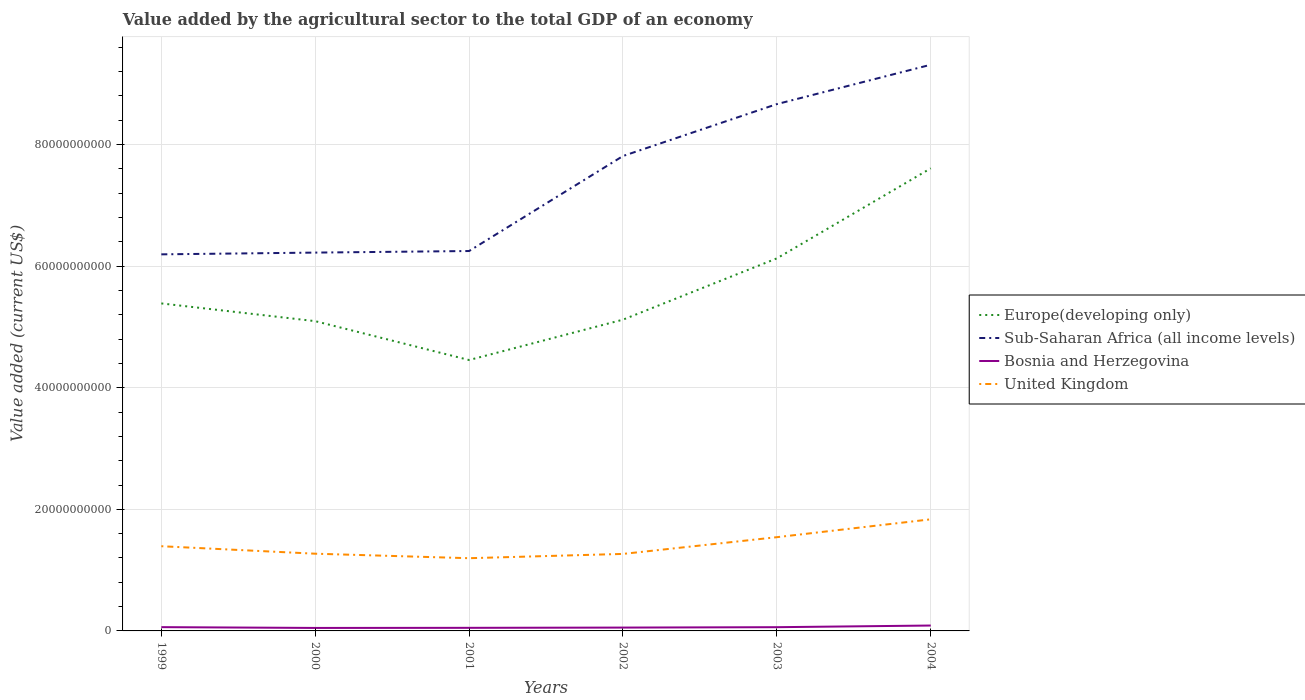Across all years, what is the maximum value added by the agricultural sector to the total GDP in Europe(developing only)?
Ensure brevity in your answer.  4.46e+1. What is the total value added by the agricultural sector to the total GDP in Bosnia and Herzegovina in the graph?
Give a very brief answer. -1.24e+08. What is the difference between the highest and the second highest value added by the agricultural sector to the total GDP in Bosnia and Herzegovina?
Offer a terse response. 3.97e+08. What is the difference between the highest and the lowest value added by the agricultural sector to the total GDP in Bosnia and Herzegovina?
Offer a very short reply. 3. Is the value added by the agricultural sector to the total GDP in United Kingdom strictly greater than the value added by the agricultural sector to the total GDP in Europe(developing only) over the years?
Make the answer very short. Yes. How many lines are there?
Offer a terse response. 4. How many years are there in the graph?
Your answer should be very brief. 6. Does the graph contain any zero values?
Your answer should be compact. No. Does the graph contain grids?
Your response must be concise. Yes. Where does the legend appear in the graph?
Provide a short and direct response. Center right. How are the legend labels stacked?
Offer a terse response. Vertical. What is the title of the graph?
Provide a succinct answer. Value added by the agricultural sector to the total GDP of an economy. Does "Kyrgyz Republic" appear as one of the legend labels in the graph?
Provide a short and direct response. No. What is the label or title of the Y-axis?
Provide a short and direct response. Value added (current US$). What is the Value added (current US$) of Europe(developing only) in 1999?
Provide a succinct answer. 5.39e+1. What is the Value added (current US$) in Sub-Saharan Africa (all income levels) in 1999?
Make the answer very short. 6.19e+1. What is the Value added (current US$) of Bosnia and Herzegovina in 1999?
Keep it short and to the point. 6.21e+08. What is the Value added (current US$) of United Kingdom in 1999?
Your answer should be compact. 1.39e+1. What is the Value added (current US$) in Europe(developing only) in 2000?
Make the answer very short. 5.10e+1. What is the Value added (current US$) of Sub-Saharan Africa (all income levels) in 2000?
Offer a terse response. 6.22e+1. What is the Value added (current US$) of Bosnia and Herzegovina in 2000?
Keep it short and to the point. 4.90e+08. What is the Value added (current US$) of United Kingdom in 2000?
Keep it short and to the point. 1.27e+1. What is the Value added (current US$) in Europe(developing only) in 2001?
Offer a terse response. 4.46e+1. What is the Value added (current US$) in Sub-Saharan Africa (all income levels) in 2001?
Ensure brevity in your answer.  6.25e+1. What is the Value added (current US$) in Bosnia and Herzegovina in 2001?
Your response must be concise. 5.10e+08. What is the Value added (current US$) of United Kingdom in 2001?
Your answer should be very brief. 1.20e+1. What is the Value added (current US$) in Europe(developing only) in 2002?
Your response must be concise. 5.12e+1. What is the Value added (current US$) in Sub-Saharan Africa (all income levels) in 2002?
Make the answer very short. 7.81e+1. What is the Value added (current US$) of Bosnia and Herzegovina in 2002?
Ensure brevity in your answer.  5.50e+08. What is the Value added (current US$) in United Kingdom in 2002?
Give a very brief answer. 1.27e+1. What is the Value added (current US$) in Europe(developing only) in 2003?
Provide a succinct answer. 6.13e+1. What is the Value added (current US$) of Sub-Saharan Africa (all income levels) in 2003?
Provide a short and direct response. 8.67e+1. What is the Value added (current US$) of Bosnia and Herzegovina in 2003?
Ensure brevity in your answer.  6.14e+08. What is the Value added (current US$) of United Kingdom in 2003?
Provide a succinct answer. 1.54e+1. What is the Value added (current US$) in Europe(developing only) in 2004?
Your answer should be compact. 7.61e+1. What is the Value added (current US$) in Sub-Saharan Africa (all income levels) in 2004?
Offer a very short reply. 9.31e+1. What is the Value added (current US$) in Bosnia and Herzegovina in 2004?
Offer a very short reply. 8.87e+08. What is the Value added (current US$) of United Kingdom in 2004?
Give a very brief answer. 1.84e+1. Across all years, what is the maximum Value added (current US$) of Europe(developing only)?
Offer a very short reply. 7.61e+1. Across all years, what is the maximum Value added (current US$) of Sub-Saharan Africa (all income levels)?
Ensure brevity in your answer.  9.31e+1. Across all years, what is the maximum Value added (current US$) in Bosnia and Herzegovina?
Provide a short and direct response. 8.87e+08. Across all years, what is the maximum Value added (current US$) of United Kingdom?
Your answer should be very brief. 1.84e+1. Across all years, what is the minimum Value added (current US$) of Europe(developing only)?
Your response must be concise. 4.46e+1. Across all years, what is the minimum Value added (current US$) of Sub-Saharan Africa (all income levels)?
Give a very brief answer. 6.19e+1. Across all years, what is the minimum Value added (current US$) in Bosnia and Herzegovina?
Offer a very short reply. 4.90e+08. Across all years, what is the minimum Value added (current US$) in United Kingdom?
Your response must be concise. 1.20e+1. What is the total Value added (current US$) of Europe(developing only) in the graph?
Offer a very short reply. 3.38e+11. What is the total Value added (current US$) in Sub-Saharan Africa (all income levels) in the graph?
Give a very brief answer. 4.45e+11. What is the total Value added (current US$) of Bosnia and Herzegovina in the graph?
Ensure brevity in your answer.  3.67e+09. What is the total Value added (current US$) in United Kingdom in the graph?
Ensure brevity in your answer.  8.50e+1. What is the difference between the Value added (current US$) of Europe(developing only) in 1999 and that in 2000?
Ensure brevity in your answer.  2.92e+09. What is the difference between the Value added (current US$) in Sub-Saharan Africa (all income levels) in 1999 and that in 2000?
Your answer should be very brief. -2.88e+08. What is the difference between the Value added (current US$) of Bosnia and Herzegovina in 1999 and that in 2000?
Your answer should be compact. 1.31e+08. What is the difference between the Value added (current US$) of United Kingdom in 1999 and that in 2000?
Your answer should be compact. 1.23e+09. What is the difference between the Value added (current US$) of Europe(developing only) in 1999 and that in 2001?
Your answer should be compact. 9.31e+09. What is the difference between the Value added (current US$) in Sub-Saharan Africa (all income levels) in 1999 and that in 2001?
Ensure brevity in your answer.  -5.46e+08. What is the difference between the Value added (current US$) of Bosnia and Herzegovina in 1999 and that in 2001?
Your answer should be compact. 1.12e+08. What is the difference between the Value added (current US$) in United Kingdom in 1999 and that in 2001?
Make the answer very short. 1.97e+09. What is the difference between the Value added (current US$) in Europe(developing only) in 1999 and that in 2002?
Your answer should be very brief. 2.67e+09. What is the difference between the Value added (current US$) in Sub-Saharan Africa (all income levels) in 1999 and that in 2002?
Your response must be concise. -1.62e+1. What is the difference between the Value added (current US$) in Bosnia and Herzegovina in 1999 and that in 2002?
Give a very brief answer. 7.11e+07. What is the difference between the Value added (current US$) in United Kingdom in 1999 and that in 2002?
Ensure brevity in your answer.  1.27e+09. What is the difference between the Value added (current US$) of Europe(developing only) in 1999 and that in 2003?
Provide a succinct answer. -7.41e+09. What is the difference between the Value added (current US$) of Sub-Saharan Africa (all income levels) in 1999 and that in 2003?
Offer a terse response. -2.47e+1. What is the difference between the Value added (current US$) of Bosnia and Herzegovina in 1999 and that in 2003?
Keep it short and to the point. 7.01e+06. What is the difference between the Value added (current US$) of United Kingdom in 1999 and that in 2003?
Provide a short and direct response. -1.49e+09. What is the difference between the Value added (current US$) of Europe(developing only) in 1999 and that in 2004?
Give a very brief answer. -2.22e+1. What is the difference between the Value added (current US$) of Sub-Saharan Africa (all income levels) in 1999 and that in 2004?
Your answer should be very brief. -3.12e+1. What is the difference between the Value added (current US$) of Bosnia and Herzegovina in 1999 and that in 2004?
Provide a short and direct response. -2.66e+08. What is the difference between the Value added (current US$) of United Kingdom in 1999 and that in 2004?
Keep it short and to the point. -4.42e+09. What is the difference between the Value added (current US$) of Europe(developing only) in 2000 and that in 2001?
Make the answer very short. 6.40e+09. What is the difference between the Value added (current US$) of Sub-Saharan Africa (all income levels) in 2000 and that in 2001?
Offer a terse response. -2.59e+08. What is the difference between the Value added (current US$) in Bosnia and Herzegovina in 2000 and that in 2001?
Provide a succinct answer. -1.96e+07. What is the difference between the Value added (current US$) of United Kingdom in 2000 and that in 2001?
Ensure brevity in your answer.  7.40e+08. What is the difference between the Value added (current US$) in Europe(developing only) in 2000 and that in 2002?
Your response must be concise. -2.46e+08. What is the difference between the Value added (current US$) in Sub-Saharan Africa (all income levels) in 2000 and that in 2002?
Your answer should be very brief. -1.59e+1. What is the difference between the Value added (current US$) in Bosnia and Herzegovina in 2000 and that in 2002?
Make the answer very short. -6.01e+07. What is the difference between the Value added (current US$) in United Kingdom in 2000 and that in 2002?
Offer a terse response. 3.45e+07. What is the difference between the Value added (current US$) of Europe(developing only) in 2000 and that in 2003?
Your answer should be very brief. -1.03e+1. What is the difference between the Value added (current US$) in Sub-Saharan Africa (all income levels) in 2000 and that in 2003?
Your response must be concise. -2.44e+1. What is the difference between the Value added (current US$) in Bosnia and Herzegovina in 2000 and that in 2003?
Provide a short and direct response. -1.24e+08. What is the difference between the Value added (current US$) in United Kingdom in 2000 and that in 2003?
Provide a short and direct response. -2.72e+09. What is the difference between the Value added (current US$) in Europe(developing only) in 2000 and that in 2004?
Provide a succinct answer. -2.51e+1. What is the difference between the Value added (current US$) of Sub-Saharan Africa (all income levels) in 2000 and that in 2004?
Ensure brevity in your answer.  -3.09e+1. What is the difference between the Value added (current US$) of Bosnia and Herzegovina in 2000 and that in 2004?
Your response must be concise. -3.97e+08. What is the difference between the Value added (current US$) of United Kingdom in 2000 and that in 2004?
Provide a succinct answer. -5.66e+09. What is the difference between the Value added (current US$) in Europe(developing only) in 2001 and that in 2002?
Provide a short and direct response. -6.64e+09. What is the difference between the Value added (current US$) of Sub-Saharan Africa (all income levels) in 2001 and that in 2002?
Keep it short and to the point. -1.56e+1. What is the difference between the Value added (current US$) of Bosnia and Herzegovina in 2001 and that in 2002?
Your answer should be compact. -4.05e+07. What is the difference between the Value added (current US$) of United Kingdom in 2001 and that in 2002?
Provide a succinct answer. -7.06e+08. What is the difference between the Value added (current US$) in Europe(developing only) in 2001 and that in 2003?
Give a very brief answer. -1.67e+1. What is the difference between the Value added (current US$) of Sub-Saharan Africa (all income levels) in 2001 and that in 2003?
Provide a succinct answer. -2.42e+1. What is the difference between the Value added (current US$) in Bosnia and Herzegovina in 2001 and that in 2003?
Give a very brief answer. -1.05e+08. What is the difference between the Value added (current US$) of United Kingdom in 2001 and that in 2003?
Give a very brief answer. -3.46e+09. What is the difference between the Value added (current US$) of Europe(developing only) in 2001 and that in 2004?
Give a very brief answer. -3.15e+1. What is the difference between the Value added (current US$) of Sub-Saharan Africa (all income levels) in 2001 and that in 2004?
Ensure brevity in your answer.  -3.06e+1. What is the difference between the Value added (current US$) of Bosnia and Herzegovina in 2001 and that in 2004?
Your response must be concise. -3.78e+08. What is the difference between the Value added (current US$) of United Kingdom in 2001 and that in 2004?
Offer a terse response. -6.40e+09. What is the difference between the Value added (current US$) in Europe(developing only) in 2002 and that in 2003?
Make the answer very short. -1.01e+1. What is the difference between the Value added (current US$) of Sub-Saharan Africa (all income levels) in 2002 and that in 2003?
Offer a very short reply. -8.54e+09. What is the difference between the Value added (current US$) in Bosnia and Herzegovina in 2002 and that in 2003?
Give a very brief answer. -6.41e+07. What is the difference between the Value added (current US$) in United Kingdom in 2002 and that in 2003?
Provide a succinct answer. -2.75e+09. What is the difference between the Value added (current US$) of Europe(developing only) in 2002 and that in 2004?
Your answer should be very brief. -2.49e+1. What is the difference between the Value added (current US$) in Sub-Saharan Africa (all income levels) in 2002 and that in 2004?
Provide a succinct answer. -1.50e+1. What is the difference between the Value added (current US$) of Bosnia and Herzegovina in 2002 and that in 2004?
Offer a terse response. -3.37e+08. What is the difference between the Value added (current US$) of United Kingdom in 2002 and that in 2004?
Keep it short and to the point. -5.69e+09. What is the difference between the Value added (current US$) of Europe(developing only) in 2003 and that in 2004?
Offer a very short reply. -1.48e+1. What is the difference between the Value added (current US$) of Sub-Saharan Africa (all income levels) in 2003 and that in 2004?
Offer a very short reply. -6.47e+09. What is the difference between the Value added (current US$) of Bosnia and Herzegovina in 2003 and that in 2004?
Provide a succinct answer. -2.73e+08. What is the difference between the Value added (current US$) of United Kingdom in 2003 and that in 2004?
Offer a very short reply. -2.94e+09. What is the difference between the Value added (current US$) in Europe(developing only) in 1999 and the Value added (current US$) in Sub-Saharan Africa (all income levels) in 2000?
Ensure brevity in your answer.  -8.36e+09. What is the difference between the Value added (current US$) of Europe(developing only) in 1999 and the Value added (current US$) of Bosnia and Herzegovina in 2000?
Keep it short and to the point. 5.34e+1. What is the difference between the Value added (current US$) of Europe(developing only) in 1999 and the Value added (current US$) of United Kingdom in 2000?
Offer a terse response. 4.12e+1. What is the difference between the Value added (current US$) of Sub-Saharan Africa (all income levels) in 1999 and the Value added (current US$) of Bosnia and Herzegovina in 2000?
Your response must be concise. 6.15e+1. What is the difference between the Value added (current US$) of Sub-Saharan Africa (all income levels) in 1999 and the Value added (current US$) of United Kingdom in 2000?
Make the answer very short. 4.92e+1. What is the difference between the Value added (current US$) in Bosnia and Herzegovina in 1999 and the Value added (current US$) in United Kingdom in 2000?
Your response must be concise. -1.21e+1. What is the difference between the Value added (current US$) in Europe(developing only) in 1999 and the Value added (current US$) in Sub-Saharan Africa (all income levels) in 2001?
Your response must be concise. -8.62e+09. What is the difference between the Value added (current US$) in Europe(developing only) in 1999 and the Value added (current US$) in Bosnia and Herzegovina in 2001?
Offer a very short reply. 5.34e+1. What is the difference between the Value added (current US$) in Europe(developing only) in 1999 and the Value added (current US$) in United Kingdom in 2001?
Offer a very short reply. 4.19e+1. What is the difference between the Value added (current US$) in Sub-Saharan Africa (all income levels) in 1999 and the Value added (current US$) in Bosnia and Herzegovina in 2001?
Give a very brief answer. 6.14e+1. What is the difference between the Value added (current US$) in Sub-Saharan Africa (all income levels) in 1999 and the Value added (current US$) in United Kingdom in 2001?
Ensure brevity in your answer.  5.00e+1. What is the difference between the Value added (current US$) in Bosnia and Herzegovina in 1999 and the Value added (current US$) in United Kingdom in 2001?
Your answer should be very brief. -1.13e+1. What is the difference between the Value added (current US$) of Europe(developing only) in 1999 and the Value added (current US$) of Sub-Saharan Africa (all income levels) in 2002?
Give a very brief answer. -2.42e+1. What is the difference between the Value added (current US$) of Europe(developing only) in 1999 and the Value added (current US$) of Bosnia and Herzegovina in 2002?
Your response must be concise. 5.33e+1. What is the difference between the Value added (current US$) in Europe(developing only) in 1999 and the Value added (current US$) in United Kingdom in 2002?
Offer a very short reply. 4.12e+1. What is the difference between the Value added (current US$) of Sub-Saharan Africa (all income levels) in 1999 and the Value added (current US$) of Bosnia and Herzegovina in 2002?
Ensure brevity in your answer.  6.14e+1. What is the difference between the Value added (current US$) in Sub-Saharan Africa (all income levels) in 1999 and the Value added (current US$) in United Kingdom in 2002?
Make the answer very short. 4.93e+1. What is the difference between the Value added (current US$) in Bosnia and Herzegovina in 1999 and the Value added (current US$) in United Kingdom in 2002?
Ensure brevity in your answer.  -1.20e+1. What is the difference between the Value added (current US$) of Europe(developing only) in 1999 and the Value added (current US$) of Sub-Saharan Africa (all income levels) in 2003?
Keep it short and to the point. -3.28e+1. What is the difference between the Value added (current US$) in Europe(developing only) in 1999 and the Value added (current US$) in Bosnia and Herzegovina in 2003?
Your answer should be compact. 5.33e+1. What is the difference between the Value added (current US$) of Europe(developing only) in 1999 and the Value added (current US$) of United Kingdom in 2003?
Provide a short and direct response. 3.85e+1. What is the difference between the Value added (current US$) in Sub-Saharan Africa (all income levels) in 1999 and the Value added (current US$) in Bosnia and Herzegovina in 2003?
Keep it short and to the point. 6.13e+1. What is the difference between the Value added (current US$) of Sub-Saharan Africa (all income levels) in 1999 and the Value added (current US$) of United Kingdom in 2003?
Keep it short and to the point. 4.65e+1. What is the difference between the Value added (current US$) in Bosnia and Herzegovina in 1999 and the Value added (current US$) in United Kingdom in 2003?
Keep it short and to the point. -1.48e+1. What is the difference between the Value added (current US$) of Europe(developing only) in 1999 and the Value added (current US$) of Sub-Saharan Africa (all income levels) in 2004?
Make the answer very short. -3.93e+1. What is the difference between the Value added (current US$) in Europe(developing only) in 1999 and the Value added (current US$) in Bosnia and Herzegovina in 2004?
Make the answer very short. 5.30e+1. What is the difference between the Value added (current US$) of Europe(developing only) in 1999 and the Value added (current US$) of United Kingdom in 2004?
Give a very brief answer. 3.55e+1. What is the difference between the Value added (current US$) of Sub-Saharan Africa (all income levels) in 1999 and the Value added (current US$) of Bosnia and Herzegovina in 2004?
Your answer should be very brief. 6.11e+1. What is the difference between the Value added (current US$) in Sub-Saharan Africa (all income levels) in 1999 and the Value added (current US$) in United Kingdom in 2004?
Provide a succinct answer. 4.36e+1. What is the difference between the Value added (current US$) of Bosnia and Herzegovina in 1999 and the Value added (current US$) of United Kingdom in 2004?
Your response must be concise. -1.77e+1. What is the difference between the Value added (current US$) in Europe(developing only) in 2000 and the Value added (current US$) in Sub-Saharan Africa (all income levels) in 2001?
Make the answer very short. -1.15e+1. What is the difference between the Value added (current US$) of Europe(developing only) in 2000 and the Value added (current US$) of Bosnia and Herzegovina in 2001?
Offer a terse response. 5.04e+1. What is the difference between the Value added (current US$) in Europe(developing only) in 2000 and the Value added (current US$) in United Kingdom in 2001?
Offer a terse response. 3.90e+1. What is the difference between the Value added (current US$) in Sub-Saharan Africa (all income levels) in 2000 and the Value added (current US$) in Bosnia and Herzegovina in 2001?
Your response must be concise. 6.17e+1. What is the difference between the Value added (current US$) of Sub-Saharan Africa (all income levels) in 2000 and the Value added (current US$) of United Kingdom in 2001?
Give a very brief answer. 5.03e+1. What is the difference between the Value added (current US$) in Bosnia and Herzegovina in 2000 and the Value added (current US$) in United Kingdom in 2001?
Ensure brevity in your answer.  -1.15e+1. What is the difference between the Value added (current US$) in Europe(developing only) in 2000 and the Value added (current US$) in Sub-Saharan Africa (all income levels) in 2002?
Your answer should be very brief. -2.72e+1. What is the difference between the Value added (current US$) of Europe(developing only) in 2000 and the Value added (current US$) of Bosnia and Herzegovina in 2002?
Make the answer very short. 5.04e+1. What is the difference between the Value added (current US$) in Europe(developing only) in 2000 and the Value added (current US$) in United Kingdom in 2002?
Keep it short and to the point. 3.83e+1. What is the difference between the Value added (current US$) of Sub-Saharan Africa (all income levels) in 2000 and the Value added (current US$) of Bosnia and Herzegovina in 2002?
Your answer should be compact. 6.17e+1. What is the difference between the Value added (current US$) of Sub-Saharan Africa (all income levels) in 2000 and the Value added (current US$) of United Kingdom in 2002?
Give a very brief answer. 4.96e+1. What is the difference between the Value added (current US$) of Bosnia and Herzegovina in 2000 and the Value added (current US$) of United Kingdom in 2002?
Offer a very short reply. -1.22e+1. What is the difference between the Value added (current US$) of Europe(developing only) in 2000 and the Value added (current US$) of Sub-Saharan Africa (all income levels) in 2003?
Provide a short and direct response. -3.57e+1. What is the difference between the Value added (current US$) of Europe(developing only) in 2000 and the Value added (current US$) of Bosnia and Herzegovina in 2003?
Make the answer very short. 5.03e+1. What is the difference between the Value added (current US$) of Europe(developing only) in 2000 and the Value added (current US$) of United Kingdom in 2003?
Make the answer very short. 3.55e+1. What is the difference between the Value added (current US$) in Sub-Saharan Africa (all income levels) in 2000 and the Value added (current US$) in Bosnia and Herzegovina in 2003?
Make the answer very short. 6.16e+1. What is the difference between the Value added (current US$) of Sub-Saharan Africa (all income levels) in 2000 and the Value added (current US$) of United Kingdom in 2003?
Ensure brevity in your answer.  4.68e+1. What is the difference between the Value added (current US$) in Bosnia and Herzegovina in 2000 and the Value added (current US$) in United Kingdom in 2003?
Offer a very short reply. -1.49e+1. What is the difference between the Value added (current US$) in Europe(developing only) in 2000 and the Value added (current US$) in Sub-Saharan Africa (all income levels) in 2004?
Your response must be concise. -4.22e+1. What is the difference between the Value added (current US$) in Europe(developing only) in 2000 and the Value added (current US$) in Bosnia and Herzegovina in 2004?
Make the answer very short. 5.01e+1. What is the difference between the Value added (current US$) in Europe(developing only) in 2000 and the Value added (current US$) in United Kingdom in 2004?
Provide a succinct answer. 3.26e+1. What is the difference between the Value added (current US$) of Sub-Saharan Africa (all income levels) in 2000 and the Value added (current US$) of Bosnia and Herzegovina in 2004?
Give a very brief answer. 6.13e+1. What is the difference between the Value added (current US$) in Sub-Saharan Africa (all income levels) in 2000 and the Value added (current US$) in United Kingdom in 2004?
Your response must be concise. 4.39e+1. What is the difference between the Value added (current US$) in Bosnia and Herzegovina in 2000 and the Value added (current US$) in United Kingdom in 2004?
Your answer should be very brief. -1.79e+1. What is the difference between the Value added (current US$) in Europe(developing only) in 2001 and the Value added (current US$) in Sub-Saharan Africa (all income levels) in 2002?
Your response must be concise. -3.36e+1. What is the difference between the Value added (current US$) in Europe(developing only) in 2001 and the Value added (current US$) in Bosnia and Herzegovina in 2002?
Keep it short and to the point. 4.40e+1. What is the difference between the Value added (current US$) in Europe(developing only) in 2001 and the Value added (current US$) in United Kingdom in 2002?
Provide a succinct answer. 3.19e+1. What is the difference between the Value added (current US$) of Sub-Saharan Africa (all income levels) in 2001 and the Value added (current US$) of Bosnia and Herzegovina in 2002?
Offer a terse response. 6.19e+1. What is the difference between the Value added (current US$) of Sub-Saharan Africa (all income levels) in 2001 and the Value added (current US$) of United Kingdom in 2002?
Offer a terse response. 4.98e+1. What is the difference between the Value added (current US$) in Bosnia and Herzegovina in 2001 and the Value added (current US$) in United Kingdom in 2002?
Keep it short and to the point. -1.22e+1. What is the difference between the Value added (current US$) of Europe(developing only) in 2001 and the Value added (current US$) of Sub-Saharan Africa (all income levels) in 2003?
Your answer should be compact. -4.21e+1. What is the difference between the Value added (current US$) in Europe(developing only) in 2001 and the Value added (current US$) in Bosnia and Herzegovina in 2003?
Ensure brevity in your answer.  4.39e+1. What is the difference between the Value added (current US$) in Europe(developing only) in 2001 and the Value added (current US$) in United Kingdom in 2003?
Give a very brief answer. 2.91e+1. What is the difference between the Value added (current US$) in Sub-Saharan Africa (all income levels) in 2001 and the Value added (current US$) in Bosnia and Herzegovina in 2003?
Your answer should be compact. 6.19e+1. What is the difference between the Value added (current US$) of Sub-Saharan Africa (all income levels) in 2001 and the Value added (current US$) of United Kingdom in 2003?
Give a very brief answer. 4.71e+1. What is the difference between the Value added (current US$) in Bosnia and Herzegovina in 2001 and the Value added (current US$) in United Kingdom in 2003?
Provide a succinct answer. -1.49e+1. What is the difference between the Value added (current US$) in Europe(developing only) in 2001 and the Value added (current US$) in Sub-Saharan Africa (all income levels) in 2004?
Offer a terse response. -4.86e+1. What is the difference between the Value added (current US$) in Europe(developing only) in 2001 and the Value added (current US$) in Bosnia and Herzegovina in 2004?
Provide a succinct answer. 4.37e+1. What is the difference between the Value added (current US$) in Europe(developing only) in 2001 and the Value added (current US$) in United Kingdom in 2004?
Offer a terse response. 2.62e+1. What is the difference between the Value added (current US$) of Sub-Saharan Africa (all income levels) in 2001 and the Value added (current US$) of Bosnia and Herzegovina in 2004?
Your answer should be compact. 6.16e+1. What is the difference between the Value added (current US$) in Sub-Saharan Africa (all income levels) in 2001 and the Value added (current US$) in United Kingdom in 2004?
Give a very brief answer. 4.41e+1. What is the difference between the Value added (current US$) of Bosnia and Herzegovina in 2001 and the Value added (current US$) of United Kingdom in 2004?
Make the answer very short. -1.78e+1. What is the difference between the Value added (current US$) of Europe(developing only) in 2002 and the Value added (current US$) of Sub-Saharan Africa (all income levels) in 2003?
Keep it short and to the point. -3.55e+1. What is the difference between the Value added (current US$) of Europe(developing only) in 2002 and the Value added (current US$) of Bosnia and Herzegovina in 2003?
Keep it short and to the point. 5.06e+1. What is the difference between the Value added (current US$) of Europe(developing only) in 2002 and the Value added (current US$) of United Kingdom in 2003?
Give a very brief answer. 3.58e+1. What is the difference between the Value added (current US$) of Sub-Saharan Africa (all income levels) in 2002 and the Value added (current US$) of Bosnia and Herzegovina in 2003?
Give a very brief answer. 7.75e+1. What is the difference between the Value added (current US$) in Sub-Saharan Africa (all income levels) in 2002 and the Value added (current US$) in United Kingdom in 2003?
Provide a succinct answer. 6.27e+1. What is the difference between the Value added (current US$) in Bosnia and Herzegovina in 2002 and the Value added (current US$) in United Kingdom in 2003?
Offer a very short reply. -1.49e+1. What is the difference between the Value added (current US$) in Europe(developing only) in 2002 and the Value added (current US$) in Sub-Saharan Africa (all income levels) in 2004?
Provide a succinct answer. -4.19e+1. What is the difference between the Value added (current US$) of Europe(developing only) in 2002 and the Value added (current US$) of Bosnia and Herzegovina in 2004?
Your answer should be very brief. 5.03e+1. What is the difference between the Value added (current US$) of Europe(developing only) in 2002 and the Value added (current US$) of United Kingdom in 2004?
Make the answer very short. 3.28e+1. What is the difference between the Value added (current US$) of Sub-Saharan Africa (all income levels) in 2002 and the Value added (current US$) of Bosnia and Herzegovina in 2004?
Offer a very short reply. 7.72e+1. What is the difference between the Value added (current US$) of Sub-Saharan Africa (all income levels) in 2002 and the Value added (current US$) of United Kingdom in 2004?
Provide a succinct answer. 5.98e+1. What is the difference between the Value added (current US$) in Bosnia and Herzegovina in 2002 and the Value added (current US$) in United Kingdom in 2004?
Provide a short and direct response. -1.78e+1. What is the difference between the Value added (current US$) in Europe(developing only) in 2003 and the Value added (current US$) in Sub-Saharan Africa (all income levels) in 2004?
Your answer should be compact. -3.19e+1. What is the difference between the Value added (current US$) in Europe(developing only) in 2003 and the Value added (current US$) in Bosnia and Herzegovina in 2004?
Your answer should be compact. 6.04e+1. What is the difference between the Value added (current US$) in Europe(developing only) in 2003 and the Value added (current US$) in United Kingdom in 2004?
Offer a very short reply. 4.29e+1. What is the difference between the Value added (current US$) in Sub-Saharan Africa (all income levels) in 2003 and the Value added (current US$) in Bosnia and Herzegovina in 2004?
Your answer should be very brief. 8.58e+1. What is the difference between the Value added (current US$) in Sub-Saharan Africa (all income levels) in 2003 and the Value added (current US$) in United Kingdom in 2004?
Your answer should be very brief. 6.83e+1. What is the difference between the Value added (current US$) of Bosnia and Herzegovina in 2003 and the Value added (current US$) of United Kingdom in 2004?
Make the answer very short. -1.77e+1. What is the average Value added (current US$) in Europe(developing only) per year?
Offer a terse response. 5.63e+1. What is the average Value added (current US$) of Sub-Saharan Africa (all income levels) per year?
Your response must be concise. 7.41e+1. What is the average Value added (current US$) of Bosnia and Herzegovina per year?
Offer a very short reply. 6.12e+08. What is the average Value added (current US$) in United Kingdom per year?
Make the answer very short. 1.42e+1. In the year 1999, what is the difference between the Value added (current US$) of Europe(developing only) and Value added (current US$) of Sub-Saharan Africa (all income levels)?
Your answer should be compact. -8.07e+09. In the year 1999, what is the difference between the Value added (current US$) of Europe(developing only) and Value added (current US$) of Bosnia and Herzegovina?
Offer a very short reply. 5.33e+1. In the year 1999, what is the difference between the Value added (current US$) of Europe(developing only) and Value added (current US$) of United Kingdom?
Your answer should be very brief. 3.99e+1. In the year 1999, what is the difference between the Value added (current US$) of Sub-Saharan Africa (all income levels) and Value added (current US$) of Bosnia and Herzegovina?
Your answer should be compact. 6.13e+1. In the year 1999, what is the difference between the Value added (current US$) of Sub-Saharan Africa (all income levels) and Value added (current US$) of United Kingdom?
Offer a terse response. 4.80e+1. In the year 1999, what is the difference between the Value added (current US$) in Bosnia and Herzegovina and Value added (current US$) in United Kingdom?
Your answer should be very brief. -1.33e+1. In the year 2000, what is the difference between the Value added (current US$) in Europe(developing only) and Value added (current US$) in Sub-Saharan Africa (all income levels)?
Provide a succinct answer. -1.13e+1. In the year 2000, what is the difference between the Value added (current US$) in Europe(developing only) and Value added (current US$) in Bosnia and Herzegovina?
Offer a terse response. 5.05e+1. In the year 2000, what is the difference between the Value added (current US$) in Europe(developing only) and Value added (current US$) in United Kingdom?
Your answer should be very brief. 3.83e+1. In the year 2000, what is the difference between the Value added (current US$) in Sub-Saharan Africa (all income levels) and Value added (current US$) in Bosnia and Herzegovina?
Offer a terse response. 6.17e+1. In the year 2000, what is the difference between the Value added (current US$) in Sub-Saharan Africa (all income levels) and Value added (current US$) in United Kingdom?
Your answer should be compact. 4.95e+1. In the year 2000, what is the difference between the Value added (current US$) in Bosnia and Herzegovina and Value added (current US$) in United Kingdom?
Ensure brevity in your answer.  -1.22e+1. In the year 2001, what is the difference between the Value added (current US$) in Europe(developing only) and Value added (current US$) in Sub-Saharan Africa (all income levels)?
Give a very brief answer. -1.79e+1. In the year 2001, what is the difference between the Value added (current US$) in Europe(developing only) and Value added (current US$) in Bosnia and Herzegovina?
Offer a very short reply. 4.41e+1. In the year 2001, what is the difference between the Value added (current US$) in Europe(developing only) and Value added (current US$) in United Kingdom?
Provide a succinct answer. 3.26e+1. In the year 2001, what is the difference between the Value added (current US$) in Sub-Saharan Africa (all income levels) and Value added (current US$) in Bosnia and Herzegovina?
Offer a very short reply. 6.20e+1. In the year 2001, what is the difference between the Value added (current US$) of Sub-Saharan Africa (all income levels) and Value added (current US$) of United Kingdom?
Provide a short and direct response. 5.05e+1. In the year 2001, what is the difference between the Value added (current US$) of Bosnia and Herzegovina and Value added (current US$) of United Kingdom?
Keep it short and to the point. -1.15e+1. In the year 2002, what is the difference between the Value added (current US$) in Europe(developing only) and Value added (current US$) in Sub-Saharan Africa (all income levels)?
Give a very brief answer. -2.69e+1. In the year 2002, what is the difference between the Value added (current US$) of Europe(developing only) and Value added (current US$) of Bosnia and Herzegovina?
Offer a very short reply. 5.07e+1. In the year 2002, what is the difference between the Value added (current US$) of Europe(developing only) and Value added (current US$) of United Kingdom?
Offer a very short reply. 3.85e+1. In the year 2002, what is the difference between the Value added (current US$) in Sub-Saharan Africa (all income levels) and Value added (current US$) in Bosnia and Herzegovina?
Offer a very short reply. 7.76e+1. In the year 2002, what is the difference between the Value added (current US$) in Sub-Saharan Africa (all income levels) and Value added (current US$) in United Kingdom?
Make the answer very short. 6.55e+1. In the year 2002, what is the difference between the Value added (current US$) in Bosnia and Herzegovina and Value added (current US$) in United Kingdom?
Keep it short and to the point. -1.21e+1. In the year 2003, what is the difference between the Value added (current US$) in Europe(developing only) and Value added (current US$) in Sub-Saharan Africa (all income levels)?
Your answer should be compact. -2.54e+1. In the year 2003, what is the difference between the Value added (current US$) of Europe(developing only) and Value added (current US$) of Bosnia and Herzegovina?
Your answer should be compact. 6.07e+1. In the year 2003, what is the difference between the Value added (current US$) of Europe(developing only) and Value added (current US$) of United Kingdom?
Your answer should be compact. 4.59e+1. In the year 2003, what is the difference between the Value added (current US$) of Sub-Saharan Africa (all income levels) and Value added (current US$) of Bosnia and Herzegovina?
Make the answer very short. 8.60e+1. In the year 2003, what is the difference between the Value added (current US$) in Sub-Saharan Africa (all income levels) and Value added (current US$) in United Kingdom?
Give a very brief answer. 7.12e+1. In the year 2003, what is the difference between the Value added (current US$) of Bosnia and Herzegovina and Value added (current US$) of United Kingdom?
Keep it short and to the point. -1.48e+1. In the year 2004, what is the difference between the Value added (current US$) of Europe(developing only) and Value added (current US$) of Sub-Saharan Africa (all income levels)?
Your answer should be very brief. -1.70e+1. In the year 2004, what is the difference between the Value added (current US$) in Europe(developing only) and Value added (current US$) in Bosnia and Herzegovina?
Offer a very short reply. 7.52e+1. In the year 2004, what is the difference between the Value added (current US$) of Europe(developing only) and Value added (current US$) of United Kingdom?
Make the answer very short. 5.77e+1. In the year 2004, what is the difference between the Value added (current US$) in Sub-Saharan Africa (all income levels) and Value added (current US$) in Bosnia and Herzegovina?
Provide a short and direct response. 9.22e+1. In the year 2004, what is the difference between the Value added (current US$) of Sub-Saharan Africa (all income levels) and Value added (current US$) of United Kingdom?
Your answer should be compact. 7.48e+1. In the year 2004, what is the difference between the Value added (current US$) of Bosnia and Herzegovina and Value added (current US$) of United Kingdom?
Ensure brevity in your answer.  -1.75e+1. What is the ratio of the Value added (current US$) of Europe(developing only) in 1999 to that in 2000?
Your response must be concise. 1.06. What is the ratio of the Value added (current US$) of Bosnia and Herzegovina in 1999 to that in 2000?
Provide a succinct answer. 1.27. What is the ratio of the Value added (current US$) in United Kingdom in 1999 to that in 2000?
Your answer should be very brief. 1.1. What is the ratio of the Value added (current US$) in Europe(developing only) in 1999 to that in 2001?
Your answer should be very brief. 1.21. What is the ratio of the Value added (current US$) in Bosnia and Herzegovina in 1999 to that in 2001?
Provide a succinct answer. 1.22. What is the ratio of the Value added (current US$) of United Kingdom in 1999 to that in 2001?
Your response must be concise. 1.16. What is the ratio of the Value added (current US$) of Europe(developing only) in 1999 to that in 2002?
Keep it short and to the point. 1.05. What is the ratio of the Value added (current US$) of Sub-Saharan Africa (all income levels) in 1999 to that in 2002?
Your answer should be very brief. 0.79. What is the ratio of the Value added (current US$) of Bosnia and Herzegovina in 1999 to that in 2002?
Your answer should be very brief. 1.13. What is the ratio of the Value added (current US$) of United Kingdom in 1999 to that in 2002?
Your answer should be very brief. 1.1. What is the ratio of the Value added (current US$) of Europe(developing only) in 1999 to that in 2003?
Your response must be concise. 0.88. What is the ratio of the Value added (current US$) in Sub-Saharan Africa (all income levels) in 1999 to that in 2003?
Your answer should be compact. 0.71. What is the ratio of the Value added (current US$) of Bosnia and Herzegovina in 1999 to that in 2003?
Your response must be concise. 1.01. What is the ratio of the Value added (current US$) in United Kingdom in 1999 to that in 2003?
Make the answer very short. 0.9. What is the ratio of the Value added (current US$) of Europe(developing only) in 1999 to that in 2004?
Ensure brevity in your answer.  0.71. What is the ratio of the Value added (current US$) of Sub-Saharan Africa (all income levels) in 1999 to that in 2004?
Provide a succinct answer. 0.67. What is the ratio of the Value added (current US$) of Bosnia and Herzegovina in 1999 to that in 2004?
Provide a short and direct response. 0.7. What is the ratio of the Value added (current US$) of United Kingdom in 1999 to that in 2004?
Keep it short and to the point. 0.76. What is the ratio of the Value added (current US$) in Europe(developing only) in 2000 to that in 2001?
Give a very brief answer. 1.14. What is the ratio of the Value added (current US$) of Sub-Saharan Africa (all income levels) in 2000 to that in 2001?
Offer a terse response. 1. What is the ratio of the Value added (current US$) in Bosnia and Herzegovina in 2000 to that in 2001?
Offer a very short reply. 0.96. What is the ratio of the Value added (current US$) of United Kingdom in 2000 to that in 2001?
Give a very brief answer. 1.06. What is the ratio of the Value added (current US$) of Europe(developing only) in 2000 to that in 2002?
Your answer should be compact. 1. What is the ratio of the Value added (current US$) of Sub-Saharan Africa (all income levels) in 2000 to that in 2002?
Give a very brief answer. 0.8. What is the ratio of the Value added (current US$) of Bosnia and Herzegovina in 2000 to that in 2002?
Offer a very short reply. 0.89. What is the ratio of the Value added (current US$) in Europe(developing only) in 2000 to that in 2003?
Offer a terse response. 0.83. What is the ratio of the Value added (current US$) of Sub-Saharan Africa (all income levels) in 2000 to that in 2003?
Make the answer very short. 0.72. What is the ratio of the Value added (current US$) of Bosnia and Herzegovina in 2000 to that in 2003?
Provide a succinct answer. 0.8. What is the ratio of the Value added (current US$) in United Kingdom in 2000 to that in 2003?
Provide a succinct answer. 0.82. What is the ratio of the Value added (current US$) in Europe(developing only) in 2000 to that in 2004?
Provide a short and direct response. 0.67. What is the ratio of the Value added (current US$) in Sub-Saharan Africa (all income levels) in 2000 to that in 2004?
Your answer should be compact. 0.67. What is the ratio of the Value added (current US$) of Bosnia and Herzegovina in 2000 to that in 2004?
Give a very brief answer. 0.55. What is the ratio of the Value added (current US$) in United Kingdom in 2000 to that in 2004?
Give a very brief answer. 0.69. What is the ratio of the Value added (current US$) in Europe(developing only) in 2001 to that in 2002?
Provide a short and direct response. 0.87. What is the ratio of the Value added (current US$) in Sub-Saharan Africa (all income levels) in 2001 to that in 2002?
Keep it short and to the point. 0.8. What is the ratio of the Value added (current US$) in Bosnia and Herzegovina in 2001 to that in 2002?
Make the answer very short. 0.93. What is the ratio of the Value added (current US$) in United Kingdom in 2001 to that in 2002?
Your answer should be very brief. 0.94. What is the ratio of the Value added (current US$) in Europe(developing only) in 2001 to that in 2003?
Give a very brief answer. 0.73. What is the ratio of the Value added (current US$) in Sub-Saharan Africa (all income levels) in 2001 to that in 2003?
Provide a short and direct response. 0.72. What is the ratio of the Value added (current US$) in Bosnia and Herzegovina in 2001 to that in 2003?
Your answer should be compact. 0.83. What is the ratio of the Value added (current US$) in United Kingdom in 2001 to that in 2003?
Provide a short and direct response. 0.78. What is the ratio of the Value added (current US$) of Europe(developing only) in 2001 to that in 2004?
Your response must be concise. 0.59. What is the ratio of the Value added (current US$) of Sub-Saharan Africa (all income levels) in 2001 to that in 2004?
Your answer should be compact. 0.67. What is the ratio of the Value added (current US$) of Bosnia and Herzegovina in 2001 to that in 2004?
Offer a terse response. 0.57. What is the ratio of the Value added (current US$) of United Kingdom in 2001 to that in 2004?
Keep it short and to the point. 0.65. What is the ratio of the Value added (current US$) in Europe(developing only) in 2002 to that in 2003?
Ensure brevity in your answer.  0.84. What is the ratio of the Value added (current US$) of Sub-Saharan Africa (all income levels) in 2002 to that in 2003?
Offer a terse response. 0.9. What is the ratio of the Value added (current US$) in Bosnia and Herzegovina in 2002 to that in 2003?
Your response must be concise. 0.9. What is the ratio of the Value added (current US$) in United Kingdom in 2002 to that in 2003?
Your answer should be very brief. 0.82. What is the ratio of the Value added (current US$) in Europe(developing only) in 2002 to that in 2004?
Your answer should be compact. 0.67. What is the ratio of the Value added (current US$) of Sub-Saharan Africa (all income levels) in 2002 to that in 2004?
Ensure brevity in your answer.  0.84. What is the ratio of the Value added (current US$) of Bosnia and Herzegovina in 2002 to that in 2004?
Your answer should be very brief. 0.62. What is the ratio of the Value added (current US$) of United Kingdom in 2002 to that in 2004?
Offer a terse response. 0.69. What is the ratio of the Value added (current US$) of Europe(developing only) in 2003 to that in 2004?
Ensure brevity in your answer.  0.81. What is the ratio of the Value added (current US$) in Sub-Saharan Africa (all income levels) in 2003 to that in 2004?
Give a very brief answer. 0.93. What is the ratio of the Value added (current US$) of Bosnia and Herzegovina in 2003 to that in 2004?
Keep it short and to the point. 0.69. What is the ratio of the Value added (current US$) in United Kingdom in 2003 to that in 2004?
Your response must be concise. 0.84. What is the difference between the highest and the second highest Value added (current US$) of Europe(developing only)?
Your response must be concise. 1.48e+1. What is the difference between the highest and the second highest Value added (current US$) of Sub-Saharan Africa (all income levels)?
Ensure brevity in your answer.  6.47e+09. What is the difference between the highest and the second highest Value added (current US$) in Bosnia and Herzegovina?
Your response must be concise. 2.66e+08. What is the difference between the highest and the second highest Value added (current US$) of United Kingdom?
Your answer should be very brief. 2.94e+09. What is the difference between the highest and the lowest Value added (current US$) of Europe(developing only)?
Ensure brevity in your answer.  3.15e+1. What is the difference between the highest and the lowest Value added (current US$) of Sub-Saharan Africa (all income levels)?
Keep it short and to the point. 3.12e+1. What is the difference between the highest and the lowest Value added (current US$) in Bosnia and Herzegovina?
Provide a short and direct response. 3.97e+08. What is the difference between the highest and the lowest Value added (current US$) in United Kingdom?
Your answer should be compact. 6.40e+09. 